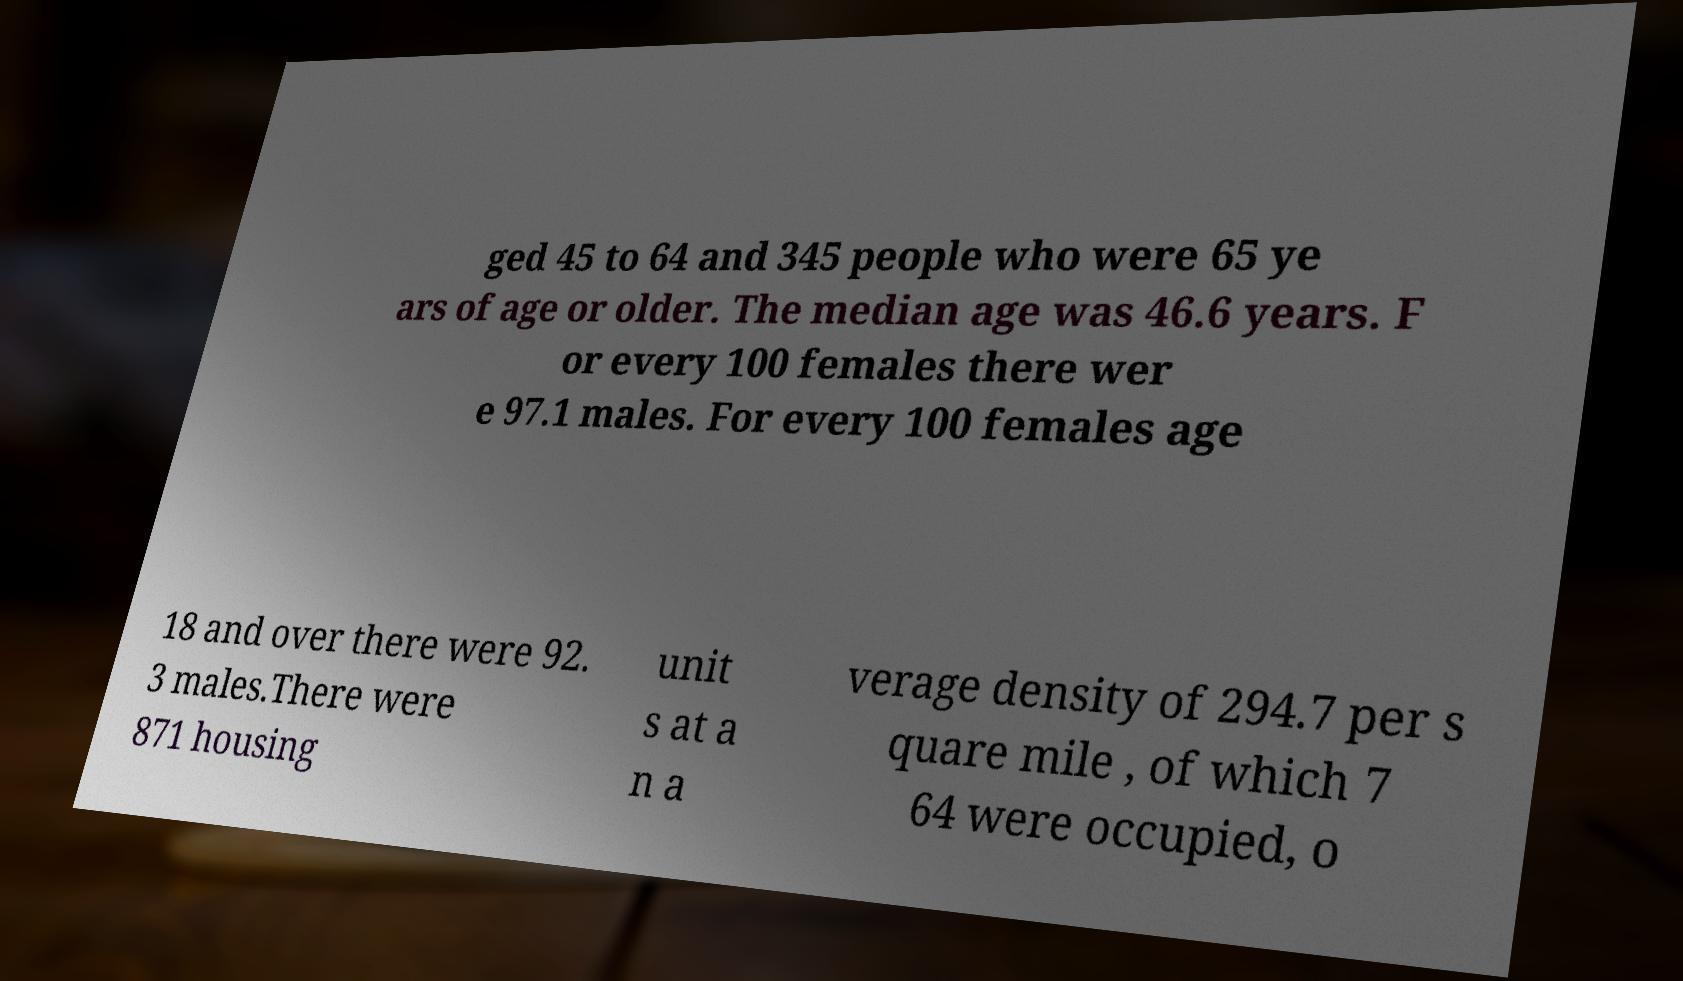Please identify and transcribe the text found in this image. ged 45 to 64 and 345 people who were 65 ye ars of age or older. The median age was 46.6 years. F or every 100 females there wer e 97.1 males. For every 100 females age 18 and over there were 92. 3 males.There were 871 housing unit s at a n a verage density of 294.7 per s quare mile , of which 7 64 were occupied, o 